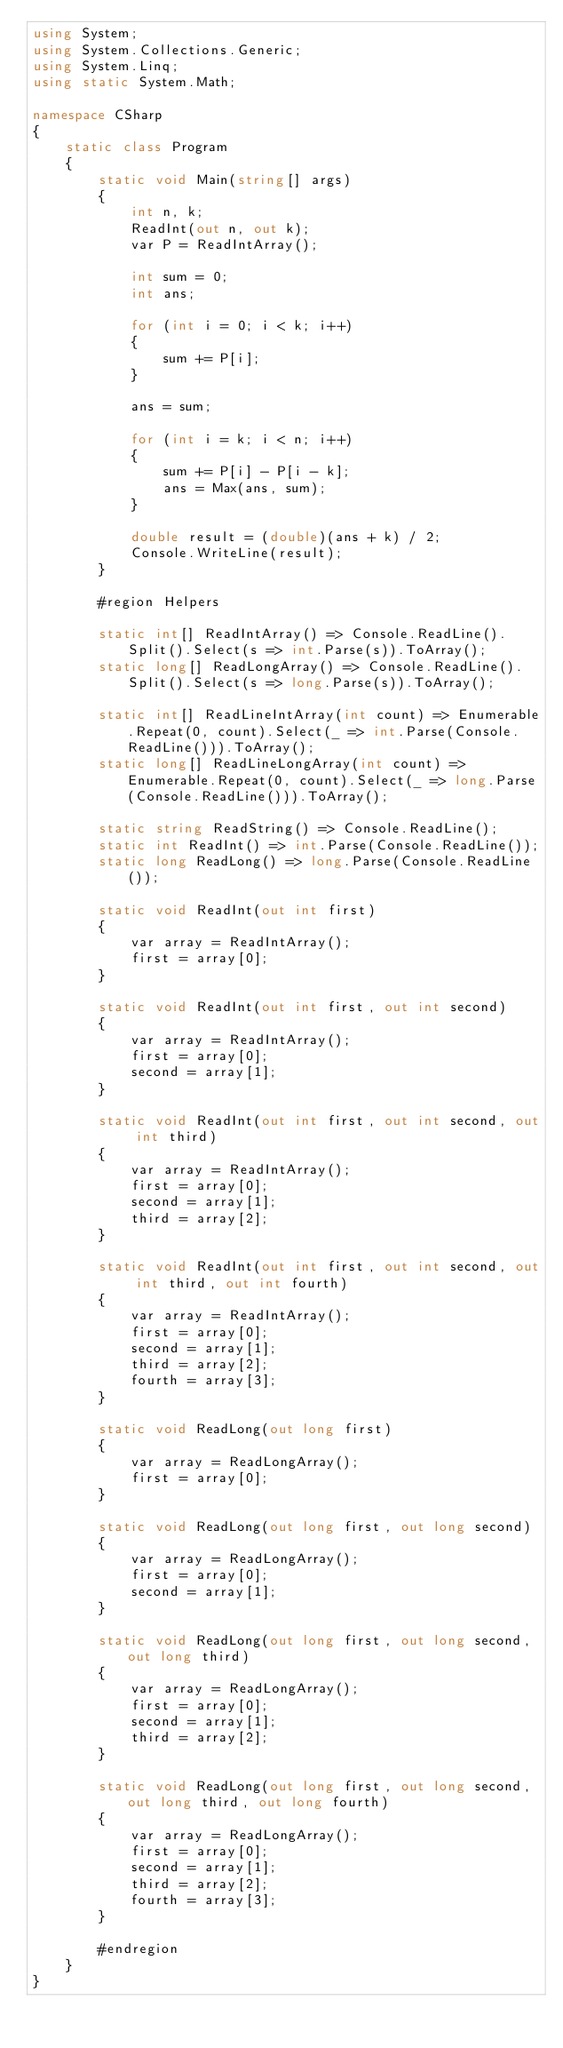<code> <loc_0><loc_0><loc_500><loc_500><_C#_>using System;
using System.Collections.Generic;
using System.Linq;
using static System.Math;

namespace CSharp
{
    static class Program
    {
        static void Main(string[] args)
        {
            int n, k;
            ReadInt(out n, out k);
            var P = ReadIntArray();

            int sum = 0;
            int ans;

            for (int i = 0; i < k; i++)
            {
                sum += P[i];
            }

            ans = sum;

            for (int i = k; i < n; i++)
            {
                sum += P[i] - P[i - k];
                ans = Max(ans, sum);
            }

            double result = (double)(ans + k) / 2;
            Console.WriteLine(result);
        }

        #region Helpers

        static int[] ReadIntArray() => Console.ReadLine().Split().Select(s => int.Parse(s)).ToArray();
        static long[] ReadLongArray() => Console.ReadLine().Split().Select(s => long.Parse(s)).ToArray();

        static int[] ReadLineIntArray(int count) => Enumerable.Repeat(0, count).Select(_ => int.Parse(Console.ReadLine())).ToArray();
        static long[] ReadLineLongArray(int count) => Enumerable.Repeat(0, count).Select(_ => long.Parse(Console.ReadLine())).ToArray();

        static string ReadString() => Console.ReadLine();
        static int ReadInt() => int.Parse(Console.ReadLine());
        static long ReadLong() => long.Parse(Console.ReadLine());

        static void ReadInt(out int first)
        {
            var array = ReadIntArray();
            first = array[0];
        }

        static void ReadInt(out int first, out int second)
        {
            var array = ReadIntArray();
            first = array[0];
            second = array[1];
        }

        static void ReadInt(out int first, out int second, out int third)
        {
            var array = ReadIntArray();
            first = array[0];
            second = array[1];
            third = array[2];
        }

        static void ReadInt(out int first, out int second, out int third, out int fourth)
        {
            var array = ReadIntArray();
            first = array[0];
            second = array[1];
            third = array[2];
            fourth = array[3];
        }

        static void ReadLong(out long first)
        {
            var array = ReadLongArray();
            first = array[0];
        }

        static void ReadLong(out long first, out long second)
        {
            var array = ReadLongArray();
            first = array[0];
            second = array[1];
        }

        static void ReadLong(out long first, out long second, out long third)
        {
            var array = ReadLongArray();
            first = array[0];
            second = array[1];
            third = array[2];
        }

        static void ReadLong(out long first, out long second, out long third, out long fourth)
        {
            var array = ReadLongArray();
            first = array[0];
            second = array[1];
            third = array[2];
            fourth = array[3];
        }

        #endregion
    }
}</code> 